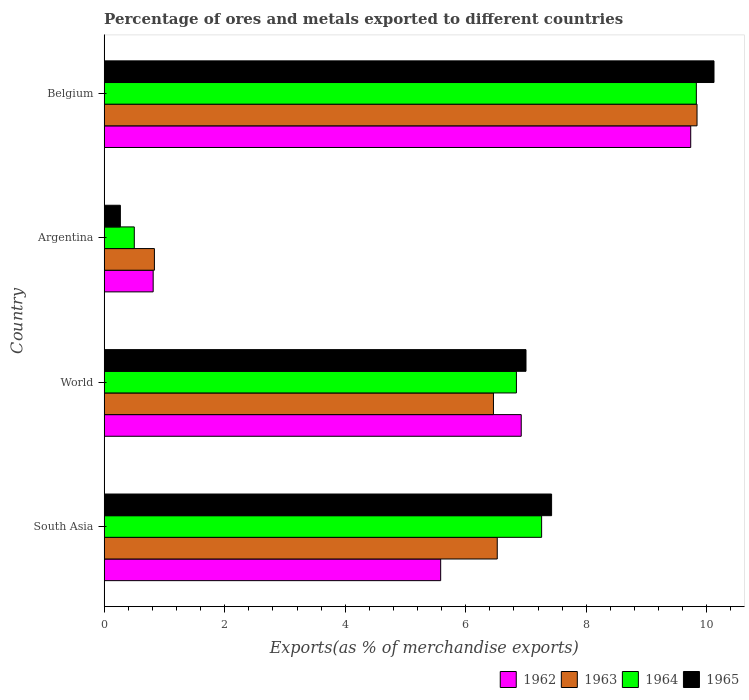How many different coloured bars are there?
Offer a terse response. 4. How many groups of bars are there?
Keep it short and to the point. 4. How many bars are there on the 4th tick from the bottom?
Make the answer very short. 4. In how many cases, is the number of bars for a given country not equal to the number of legend labels?
Offer a terse response. 0. What is the percentage of exports to different countries in 1963 in Argentina?
Your response must be concise. 0.83. Across all countries, what is the maximum percentage of exports to different countries in 1963?
Offer a terse response. 9.84. Across all countries, what is the minimum percentage of exports to different countries in 1964?
Give a very brief answer. 0.5. What is the total percentage of exports to different countries in 1965 in the graph?
Keep it short and to the point. 24.81. What is the difference between the percentage of exports to different countries in 1965 in Argentina and that in South Asia?
Provide a succinct answer. -7.16. What is the difference between the percentage of exports to different countries in 1963 in South Asia and the percentage of exports to different countries in 1964 in Argentina?
Provide a short and direct response. 6.02. What is the average percentage of exports to different countries in 1962 per country?
Your response must be concise. 5.76. What is the difference between the percentage of exports to different countries in 1964 and percentage of exports to different countries in 1965 in Argentina?
Offer a terse response. 0.23. What is the ratio of the percentage of exports to different countries in 1963 in Belgium to that in World?
Your response must be concise. 1.52. Is the percentage of exports to different countries in 1965 in Argentina less than that in World?
Your response must be concise. Yes. What is the difference between the highest and the second highest percentage of exports to different countries in 1964?
Make the answer very short. 2.57. What is the difference between the highest and the lowest percentage of exports to different countries in 1963?
Ensure brevity in your answer.  9. Is it the case that in every country, the sum of the percentage of exports to different countries in 1963 and percentage of exports to different countries in 1964 is greater than the sum of percentage of exports to different countries in 1965 and percentage of exports to different countries in 1962?
Make the answer very short. No. What does the 4th bar from the top in World represents?
Your answer should be compact. 1962. What does the 4th bar from the bottom in World represents?
Your answer should be compact. 1965. What is the difference between two consecutive major ticks on the X-axis?
Provide a short and direct response. 2. Are the values on the major ticks of X-axis written in scientific E-notation?
Offer a terse response. No. Does the graph contain any zero values?
Offer a terse response. No. Does the graph contain grids?
Your answer should be very brief. No. What is the title of the graph?
Your answer should be compact. Percentage of ores and metals exported to different countries. What is the label or title of the X-axis?
Provide a short and direct response. Exports(as % of merchandise exports). What is the label or title of the Y-axis?
Your answer should be very brief. Country. What is the Exports(as % of merchandise exports) of 1962 in South Asia?
Provide a succinct answer. 5.58. What is the Exports(as % of merchandise exports) of 1963 in South Asia?
Ensure brevity in your answer.  6.52. What is the Exports(as % of merchandise exports) in 1964 in South Asia?
Your answer should be compact. 7.26. What is the Exports(as % of merchandise exports) in 1965 in South Asia?
Provide a short and direct response. 7.42. What is the Exports(as % of merchandise exports) in 1962 in World?
Provide a succinct answer. 6.92. What is the Exports(as % of merchandise exports) of 1963 in World?
Ensure brevity in your answer.  6.46. What is the Exports(as % of merchandise exports) in 1964 in World?
Provide a short and direct response. 6.84. What is the Exports(as % of merchandise exports) of 1965 in World?
Keep it short and to the point. 7. What is the Exports(as % of merchandise exports) in 1962 in Argentina?
Keep it short and to the point. 0.81. What is the Exports(as % of merchandise exports) of 1963 in Argentina?
Ensure brevity in your answer.  0.83. What is the Exports(as % of merchandise exports) in 1964 in Argentina?
Ensure brevity in your answer.  0.5. What is the Exports(as % of merchandise exports) in 1965 in Argentina?
Offer a very short reply. 0.27. What is the Exports(as % of merchandise exports) of 1962 in Belgium?
Offer a terse response. 9.73. What is the Exports(as % of merchandise exports) in 1963 in Belgium?
Offer a very short reply. 9.84. What is the Exports(as % of merchandise exports) of 1964 in Belgium?
Your response must be concise. 9.83. What is the Exports(as % of merchandise exports) in 1965 in Belgium?
Ensure brevity in your answer.  10.12. Across all countries, what is the maximum Exports(as % of merchandise exports) of 1962?
Your response must be concise. 9.73. Across all countries, what is the maximum Exports(as % of merchandise exports) of 1963?
Give a very brief answer. 9.84. Across all countries, what is the maximum Exports(as % of merchandise exports) of 1964?
Offer a very short reply. 9.83. Across all countries, what is the maximum Exports(as % of merchandise exports) of 1965?
Your response must be concise. 10.12. Across all countries, what is the minimum Exports(as % of merchandise exports) in 1962?
Keep it short and to the point. 0.81. Across all countries, what is the minimum Exports(as % of merchandise exports) in 1963?
Your answer should be compact. 0.83. Across all countries, what is the minimum Exports(as % of merchandise exports) in 1964?
Provide a short and direct response. 0.5. Across all countries, what is the minimum Exports(as % of merchandise exports) in 1965?
Provide a succinct answer. 0.27. What is the total Exports(as % of merchandise exports) of 1962 in the graph?
Your answer should be compact. 23.05. What is the total Exports(as % of merchandise exports) of 1963 in the graph?
Offer a terse response. 23.65. What is the total Exports(as % of merchandise exports) of 1964 in the graph?
Your answer should be compact. 24.43. What is the total Exports(as % of merchandise exports) in 1965 in the graph?
Keep it short and to the point. 24.81. What is the difference between the Exports(as % of merchandise exports) in 1962 in South Asia and that in World?
Make the answer very short. -1.34. What is the difference between the Exports(as % of merchandise exports) of 1963 in South Asia and that in World?
Offer a terse response. 0.06. What is the difference between the Exports(as % of merchandise exports) in 1964 in South Asia and that in World?
Give a very brief answer. 0.42. What is the difference between the Exports(as % of merchandise exports) of 1965 in South Asia and that in World?
Your answer should be compact. 0.42. What is the difference between the Exports(as % of merchandise exports) in 1962 in South Asia and that in Argentina?
Offer a very short reply. 4.77. What is the difference between the Exports(as % of merchandise exports) in 1963 in South Asia and that in Argentina?
Provide a succinct answer. 5.69. What is the difference between the Exports(as % of merchandise exports) in 1964 in South Asia and that in Argentina?
Ensure brevity in your answer.  6.76. What is the difference between the Exports(as % of merchandise exports) in 1965 in South Asia and that in Argentina?
Your answer should be very brief. 7.16. What is the difference between the Exports(as % of merchandise exports) in 1962 in South Asia and that in Belgium?
Make the answer very short. -4.15. What is the difference between the Exports(as % of merchandise exports) in 1963 in South Asia and that in Belgium?
Provide a short and direct response. -3.32. What is the difference between the Exports(as % of merchandise exports) of 1964 in South Asia and that in Belgium?
Give a very brief answer. -2.57. What is the difference between the Exports(as % of merchandise exports) in 1965 in South Asia and that in Belgium?
Your answer should be very brief. -2.69. What is the difference between the Exports(as % of merchandise exports) in 1962 in World and that in Argentina?
Your response must be concise. 6.11. What is the difference between the Exports(as % of merchandise exports) of 1963 in World and that in Argentina?
Your answer should be compact. 5.63. What is the difference between the Exports(as % of merchandise exports) in 1964 in World and that in Argentina?
Keep it short and to the point. 6.34. What is the difference between the Exports(as % of merchandise exports) in 1965 in World and that in Argentina?
Make the answer very short. 6.73. What is the difference between the Exports(as % of merchandise exports) in 1962 in World and that in Belgium?
Your answer should be compact. -2.81. What is the difference between the Exports(as % of merchandise exports) of 1963 in World and that in Belgium?
Offer a very short reply. -3.38. What is the difference between the Exports(as % of merchandise exports) of 1964 in World and that in Belgium?
Provide a succinct answer. -2.99. What is the difference between the Exports(as % of merchandise exports) of 1965 in World and that in Belgium?
Your response must be concise. -3.12. What is the difference between the Exports(as % of merchandise exports) of 1962 in Argentina and that in Belgium?
Keep it short and to the point. -8.92. What is the difference between the Exports(as % of merchandise exports) of 1963 in Argentina and that in Belgium?
Offer a terse response. -9. What is the difference between the Exports(as % of merchandise exports) of 1964 in Argentina and that in Belgium?
Ensure brevity in your answer.  -9.33. What is the difference between the Exports(as % of merchandise exports) in 1965 in Argentina and that in Belgium?
Provide a short and direct response. -9.85. What is the difference between the Exports(as % of merchandise exports) in 1962 in South Asia and the Exports(as % of merchandise exports) in 1963 in World?
Ensure brevity in your answer.  -0.88. What is the difference between the Exports(as % of merchandise exports) of 1962 in South Asia and the Exports(as % of merchandise exports) of 1964 in World?
Give a very brief answer. -1.26. What is the difference between the Exports(as % of merchandise exports) in 1962 in South Asia and the Exports(as % of merchandise exports) in 1965 in World?
Give a very brief answer. -1.42. What is the difference between the Exports(as % of merchandise exports) in 1963 in South Asia and the Exports(as % of merchandise exports) in 1964 in World?
Offer a very short reply. -0.32. What is the difference between the Exports(as % of merchandise exports) in 1963 in South Asia and the Exports(as % of merchandise exports) in 1965 in World?
Make the answer very short. -0.48. What is the difference between the Exports(as % of merchandise exports) in 1964 in South Asia and the Exports(as % of merchandise exports) in 1965 in World?
Offer a terse response. 0.26. What is the difference between the Exports(as % of merchandise exports) of 1962 in South Asia and the Exports(as % of merchandise exports) of 1963 in Argentina?
Ensure brevity in your answer.  4.75. What is the difference between the Exports(as % of merchandise exports) in 1962 in South Asia and the Exports(as % of merchandise exports) in 1964 in Argentina?
Offer a very short reply. 5.08. What is the difference between the Exports(as % of merchandise exports) of 1962 in South Asia and the Exports(as % of merchandise exports) of 1965 in Argentina?
Your answer should be very brief. 5.32. What is the difference between the Exports(as % of merchandise exports) of 1963 in South Asia and the Exports(as % of merchandise exports) of 1964 in Argentina?
Offer a terse response. 6.02. What is the difference between the Exports(as % of merchandise exports) of 1963 in South Asia and the Exports(as % of merchandise exports) of 1965 in Argentina?
Your response must be concise. 6.25. What is the difference between the Exports(as % of merchandise exports) in 1964 in South Asia and the Exports(as % of merchandise exports) in 1965 in Argentina?
Give a very brief answer. 6.99. What is the difference between the Exports(as % of merchandise exports) in 1962 in South Asia and the Exports(as % of merchandise exports) in 1963 in Belgium?
Offer a terse response. -4.25. What is the difference between the Exports(as % of merchandise exports) in 1962 in South Asia and the Exports(as % of merchandise exports) in 1964 in Belgium?
Your answer should be compact. -4.24. What is the difference between the Exports(as % of merchandise exports) of 1962 in South Asia and the Exports(as % of merchandise exports) of 1965 in Belgium?
Provide a succinct answer. -4.54. What is the difference between the Exports(as % of merchandise exports) in 1963 in South Asia and the Exports(as % of merchandise exports) in 1964 in Belgium?
Offer a very short reply. -3.3. What is the difference between the Exports(as % of merchandise exports) of 1963 in South Asia and the Exports(as % of merchandise exports) of 1965 in Belgium?
Your answer should be compact. -3.6. What is the difference between the Exports(as % of merchandise exports) in 1964 in South Asia and the Exports(as % of merchandise exports) in 1965 in Belgium?
Ensure brevity in your answer.  -2.86. What is the difference between the Exports(as % of merchandise exports) in 1962 in World and the Exports(as % of merchandise exports) in 1963 in Argentina?
Your answer should be very brief. 6.09. What is the difference between the Exports(as % of merchandise exports) of 1962 in World and the Exports(as % of merchandise exports) of 1964 in Argentina?
Make the answer very short. 6.42. What is the difference between the Exports(as % of merchandise exports) in 1962 in World and the Exports(as % of merchandise exports) in 1965 in Argentina?
Your answer should be very brief. 6.65. What is the difference between the Exports(as % of merchandise exports) of 1963 in World and the Exports(as % of merchandise exports) of 1964 in Argentina?
Keep it short and to the point. 5.96. What is the difference between the Exports(as % of merchandise exports) in 1963 in World and the Exports(as % of merchandise exports) in 1965 in Argentina?
Offer a very short reply. 6.19. What is the difference between the Exports(as % of merchandise exports) in 1964 in World and the Exports(as % of merchandise exports) in 1965 in Argentina?
Your answer should be compact. 6.57. What is the difference between the Exports(as % of merchandise exports) of 1962 in World and the Exports(as % of merchandise exports) of 1963 in Belgium?
Your response must be concise. -2.92. What is the difference between the Exports(as % of merchandise exports) of 1962 in World and the Exports(as % of merchandise exports) of 1964 in Belgium?
Offer a very short reply. -2.91. What is the difference between the Exports(as % of merchandise exports) of 1962 in World and the Exports(as % of merchandise exports) of 1965 in Belgium?
Your answer should be compact. -3.2. What is the difference between the Exports(as % of merchandise exports) in 1963 in World and the Exports(as % of merchandise exports) in 1964 in Belgium?
Offer a very short reply. -3.37. What is the difference between the Exports(as % of merchandise exports) in 1963 in World and the Exports(as % of merchandise exports) in 1965 in Belgium?
Your answer should be very brief. -3.66. What is the difference between the Exports(as % of merchandise exports) in 1964 in World and the Exports(as % of merchandise exports) in 1965 in Belgium?
Provide a succinct answer. -3.28. What is the difference between the Exports(as % of merchandise exports) of 1962 in Argentina and the Exports(as % of merchandise exports) of 1963 in Belgium?
Offer a terse response. -9.02. What is the difference between the Exports(as % of merchandise exports) in 1962 in Argentina and the Exports(as % of merchandise exports) in 1964 in Belgium?
Give a very brief answer. -9.01. What is the difference between the Exports(as % of merchandise exports) in 1962 in Argentina and the Exports(as % of merchandise exports) in 1965 in Belgium?
Give a very brief answer. -9.31. What is the difference between the Exports(as % of merchandise exports) of 1963 in Argentina and the Exports(as % of merchandise exports) of 1964 in Belgium?
Make the answer very short. -8.99. What is the difference between the Exports(as % of merchandise exports) of 1963 in Argentina and the Exports(as % of merchandise exports) of 1965 in Belgium?
Give a very brief answer. -9.29. What is the difference between the Exports(as % of merchandise exports) in 1964 in Argentina and the Exports(as % of merchandise exports) in 1965 in Belgium?
Your response must be concise. -9.62. What is the average Exports(as % of merchandise exports) in 1962 per country?
Ensure brevity in your answer.  5.76. What is the average Exports(as % of merchandise exports) in 1963 per country?
Make the answer very short. 5.91. What is the average Exports(as % of merchandise exports) in 1964 per country?
Keep it short and to the point. 6.11. What is the average Exports(as % of merchandise exports) of 1965 per country?
Your response must be concise. 6.2. What is the difference between the Exports(as % of merchandise exports) of 1962 and Exports(as % of merchandise exports) of 1963 in South Asia?
Provide a succinct answer. -0.94. What is the difference between the Exports(as % of merchandise exports) of 1962 and Exports(as % of merchandise exports) of 1964 in South Asia?
Offer a terse response. -1.68. What is the difference between the Exports(as % of merchandise exports) in 1962 and Exports(as % of merchandise exports) in 1965 in South Asia?
Provide a short and direct response. -1.84. What is the difference between the Exports(as % of merchandise exports) in 1963 and Exports(as % of merchandise exports) in 1964 in South Asia?
Give a very brief answer. -0.74. What is the difference between the Exports(as % of merchandise exports) in 1963 and Exports(as % of merchandise exports) in 1965 in South Asia?
Ensure brevity in your answer.  -0.9. What is the difference between the Exports(as % of merchandise exports) in 1964 and Exports(as % of merchandise exports) in 1965 in South Asia?
Keep it short and to the point. -0.17. What is the difference between the Exports(as % of merchandise exports) in 1962 and Exports(as % of merchandise exports) in 1963 in World?
Ensure brevity in your answer.  0.46. What is the difference between the Exports(as % of merchandise exports) in 1962 and Exports(as % of merchandise exports) in 1964 in World?
Give a very brief answer. 0.08. What is the difference between the Exports(as % of merchandise exports) of 1962 and Exports(as % of merchandise exports) of 1965 in World?
Provide a short and direct response. -0.08. What is the difference between the Exports(as % of merchandise exports) of 1963 and Exports(as % of merchandise exports) of 1964 in World?
Give a very brief answer. -0.38. What is the difference between the Exports(as % of merchandise exports) of 1963 and Exports(as % of merchandise exports) of 1965 in World?
Your response must be concise. -0.54. What is the difference between the Exports(as % of merchandise exports) in 1964 and Exports(as % of merchandise exports) in 1965 in World?
Your answer should be compact. -0.16. What is the difference between the Exports(as % of merchandise exports) of 1962 and Exports(as % of merchandise exports) of 1963 in Argentina?
Your answer should be compact. -0.02. What is the difference between the Exports(as % of merchandise exports) of 1962 and Exports(as % of merchandise exports) of 1964 in Argentina?
Offer a terse response. 0.31. What is the difference between the Exports(as % of merchandise exports) in 1962 and Exports(as % of merchandise exports) in 1965 in Argentina?
Provide a short and direct response. 0.54. What is the difference between the Exports(as % of merchandise exports) in 1963 and Exports(as % of merchandise exports) in 1964 in Argentina?
Your answer should be very brief. 0.33. What is the difference between the Exports(as % of merchandise exports) of 1963 and Exports(as % of merchandise exports) of 1965 in Argentina?
Your answer should be very brief. 0.56. What is the difference between the Exports(as % of merchandise exports) of 1964 and Exports(as % of merchandise exports) of 1965 in Argentina?
Provide a short and direct response. 0.23. What is the difference between the Exports(as % of merchandise exports) in 1962 and Exports(as % of merchandise exports) in 1963 in Belgium?
Keep it short and to the point. -0.1. What is the difference between the Exports(as % of merchandise exports) of 1962 and Exports(as % of merchandise exports) of 1964 in Belgium?
Your answer should be compact. -0.09. What is the difference between the Exports(as % of merchandise exports) of 1962 and Exports(as % of merchandise exports) of 1965 in Belgium?
Keep it short and to the point. -0.39. What is the difference between the Exports(as % of merchandise exports) in 1963 and Exports(as % of merchandise exports) in 1964 in Belgium?
Provide a succinct answer. 0.01. What is the difference between the Exports(as % of merchandise exports) in 1963 and Exports(as % of merchandise exports) in 1965 in Belgium?
Offer a terse response. -0.28. What is the difference between the Exports(as % of merchandise exports) of 1964 and Exports(as % of merchandise exports) of 1965 in Belgium?
Your answer should be very brief. -0.29. What is the ratio of the Exports(as % of merchandise exports) in 1962 in South Asia to that in World?
Make the answer very short. 0.81. What is the ratio of the Exports(as % of merchandise exports) of 1963 in South Asia to that in World?
Ensure brevity in your answer.  1.01. What is the ratio of the Exports(as % of merchandise exports) in 1964 in South Asia to that in World?
Ensure brevity in your answer.  1.06. What is the ratio of the Exports(as % of merchandise exports) in 1965 in South Asia to that in World?
Offer a very short reply. 1.06. What is the ratio of the Exports(as % of merchandise exports) of 1962 in South Asia to that in Argentina?
Your answer should be very brief. 6.87. What is the ratio of the Exports(as % of merchandise exports) in 1963 in South Asia to that in Argentina?
Give a very brief answer. 7.82. What is the ratio of the Exports(as % of merchandise exports) of 1964 in South Asia to that in Argentina?
Your response must be concise. 14.51. What is the ratio of the Exports(as % of merchandise exports) of 1965 in South Asia to that in Argentina?
Ensure brevity in your answer.  27.6. What is the ratio of the Exports(as % of merchandise exports) of 1962 in South Asia to that in Belgium?
Offer a terse response. 0.57. What is the ratio of the Exports(as % of merchandise exports) of 1963 in South Asia to that in Belgium?
Provide a succinct answer. 0.66. What is the ratio of the Exports(as % of merchandise exports) in 1964 in South Asia to that in Belgium?
Your answer should be compact. 0.74. What is the ratio of the Exports(as % of merchandise exports) of 1965 in South Asia to that in Belgium?
Your answer should be very brief. 0.73. What is the ratio of the Exports(as % of merchandise exports) of 1962 in World to that in Argentina?
Keep it short and to the point. 8.51. What is the ratio of the Exports(as % of merchandise exports) of 1963 in World to that in Argentina?
Provide a short and direct response. 7.75. What is the ratio of the Exports(as % of merchandise exports) of 1964 in World to that in Argentina?
Your response must be concise. 13.67. What is the ratio of the Exports(as % of merchandise exports) in 1965 in World to that in Argentina?
Offer a terse response. 26.02. What is the ratio of the Exports(as % of merchandise exports) in 1962 in World to that in Belgium?
Give a very brief answer. 0.71. What is the ratio of the Exports(as % of merchandise exports) in 1963 in World to that in Belgium?
Make the answer very short. 0.66. What is the ratio of the Exports(as % of merchandise exports) in 1964 in World to that in Belgium?
Make the answer very short. 0.7. What is the ratio of the Exports(as % of merchandise exports) of 1965 in World to that in Belgium?
Give a very brief answer. 0.69. What is the ratio of the Exports(as % of merchandise exports) of 1962 in Argentina to that in Belgium?
Keep it short and to the point. 0.08. What is the ratio of the Exports(as % of merchandise exports) of 1963 in Argentina to that in Belgium?
Provide a succinct answer. 0.08. What is the ratio of the Exports(as % of merchandise exports) in 1964 in Argentina to that in Belgium?
Provide a short and direct response. 0.05. What is the ratio of the Exports(as % of merchandise exports) of 1965 in Argentina to that in Belgium?
Give a very brief answer. 0.03. What is the difference between the highest and the second highest Exports(as % of merchandise exports) of 1962?
Provide a succinct answer. 2.81. What is the difference between the highest and the second highest Exports(as % of merchandise exports) of 1963?
Give a very brief answer. 3.32. What is the difference between the highest and the second highest Exports(as % of merchandise exports) of 1964?
Provide a short and direct response. 2.57. What is the difference between the highest and the second highest Exports(as % of merchandise exports) in 1965?
Provide a succinct answer. 2.69. What is the difference between the highest and the lowest Exports(as % of merchandise exports) in 1962?
Make the answer very short. 8.92. What is the difference between the highest and the lowest Exports(as % of merchandise exports) in 1963?
Give a very brief answer. 9. What is the difference between the highest and the lowest Exports(as % of merchandise exports) in 1964?
Ensure brevity in your answer.  9.33. What is the difference between the highest and the lowest Exports(as % of merchandise exports) in 1965?
Your answer should be very brief. 9.85. 